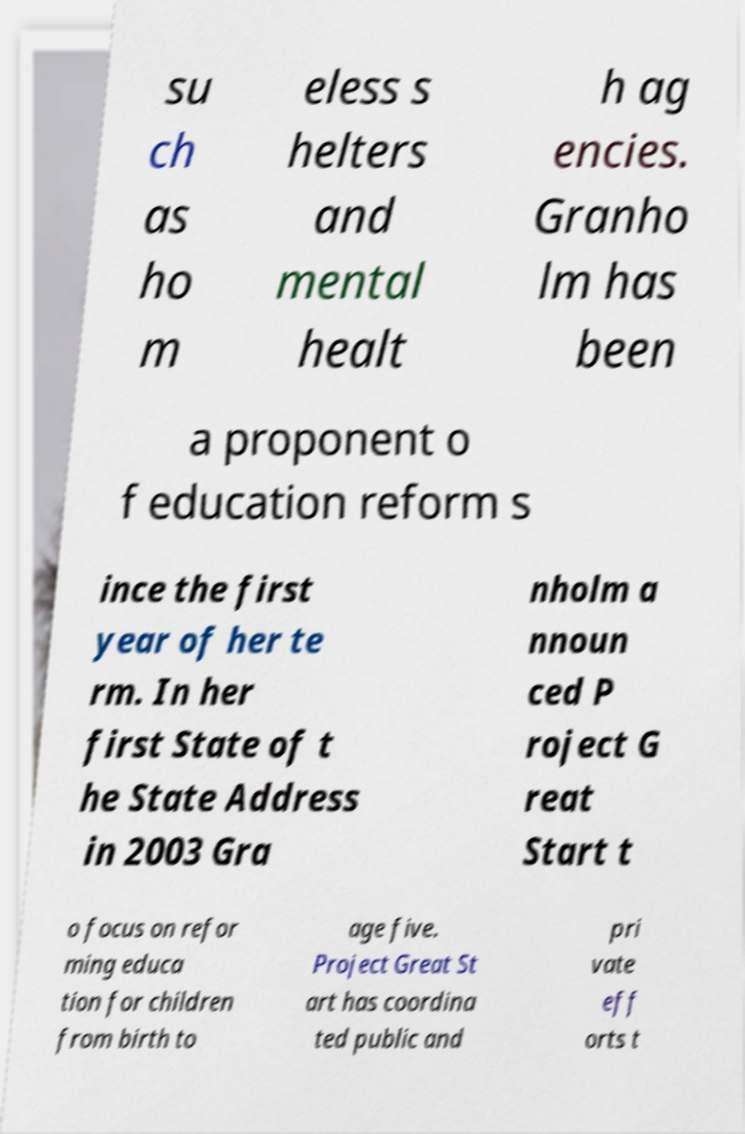There's text embedded in this image that I need extracted. Can you transcribe it verbatim? su ch as ho m eless s helters and mental healt h ag encies. Granho lm has been a proponent o f education reform s ince the first year of her te rm. In her first State of t he State Address in 2003 Gra nholm a nnoun ced P roject G reat Start t o focus on refor ming educa tion for children from birth to age five. Project Great St art has coordina ted public and pri vate eff orts t 